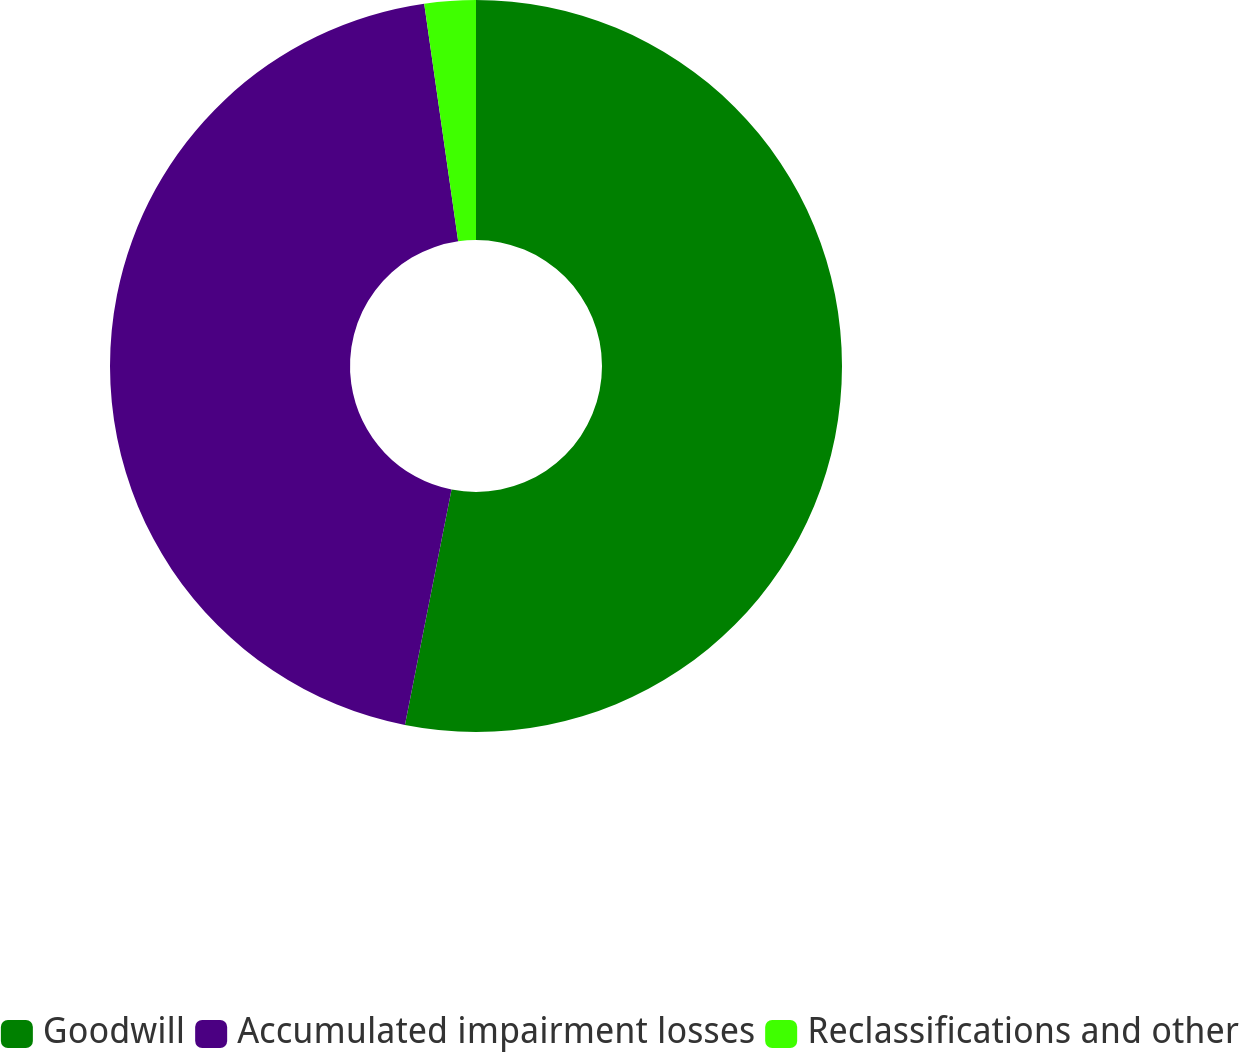<chart> <loc_0><loc_0><loc_500><loc_500><pie_chart><fcel>Goodwill<fcel>Accumulated impairment losses<fcel>Reclassifications and other<nl><fcel>53.11%<fcel>44.63%<fcel>2.26%<nl></chart> 